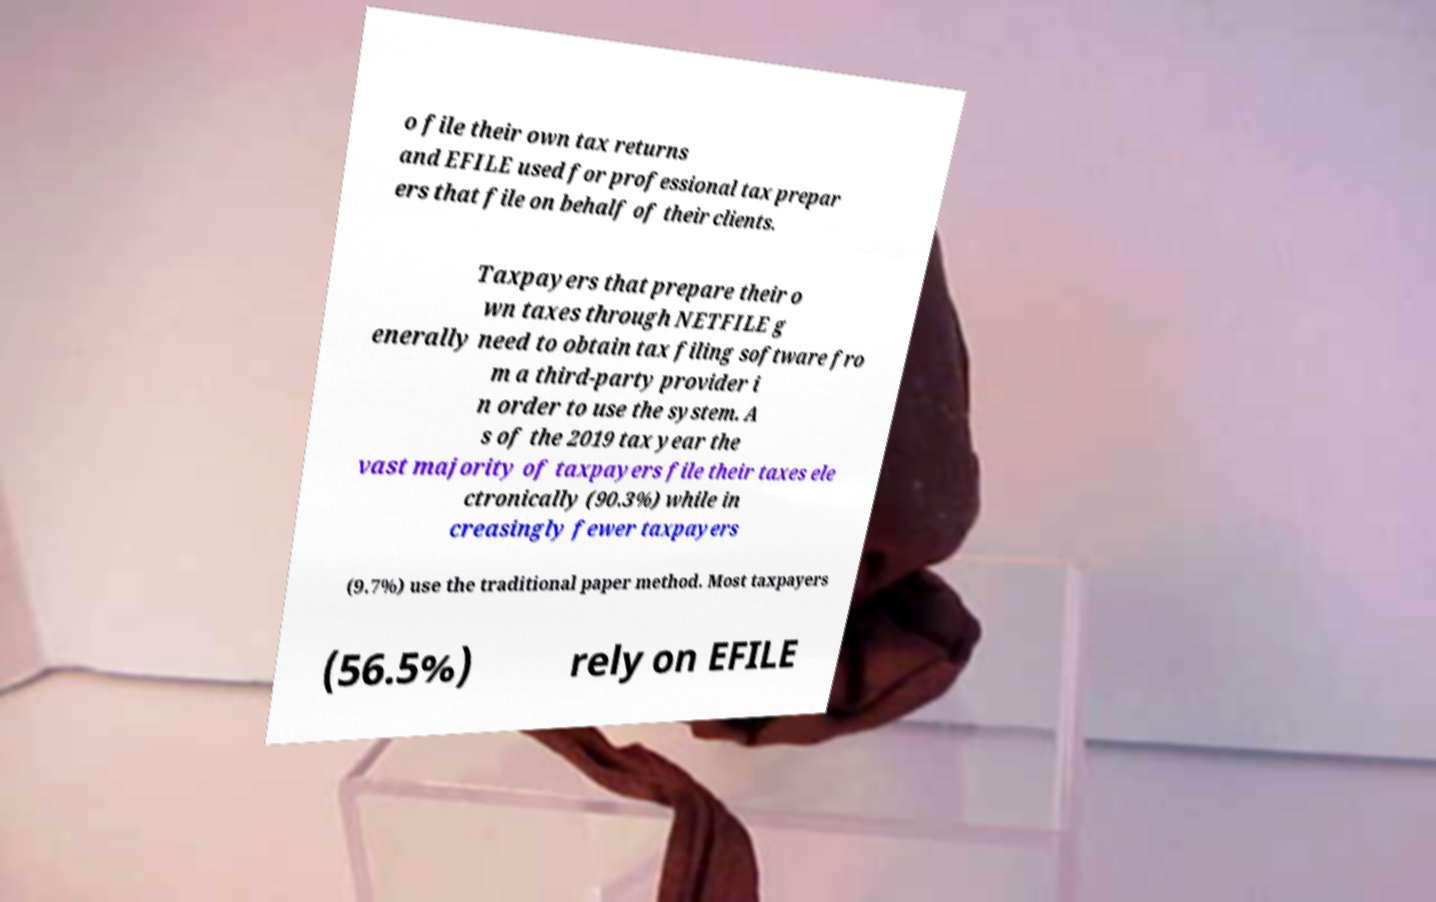Please identify and transcribe the text found in this image. o file their own tax returns and EFILE used for professional tax prepar ers that file on behalf of their clients. Taxpayers that prepare their o wn taxes through NETFILE g enerally need to obtain tax filing software fro m a third-party provider i n order to use the system. A s of the 2019 tax year the vast majority of taxpayers file their taxes ele ctronically (90.3%) while in creasingly fewer taxpayers (9.7%) use the traditional paper method. Most taxpayers (56.5%) rely on EFILE 